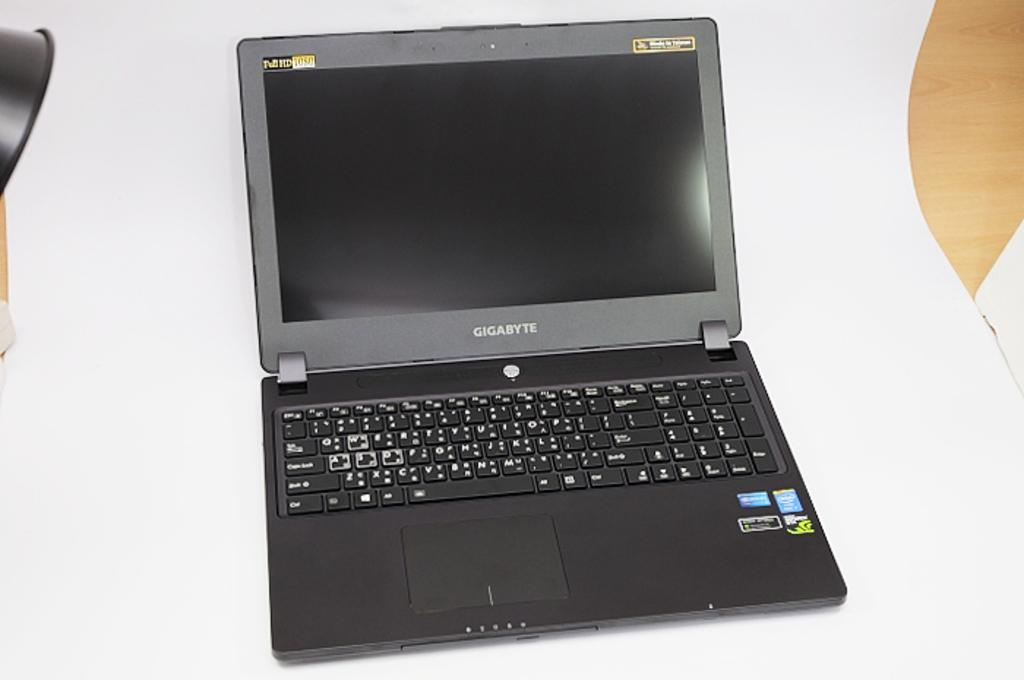<image>
Present a compact description of the photo's key features. A Gigabyte laptop in black sits open but powered off. 